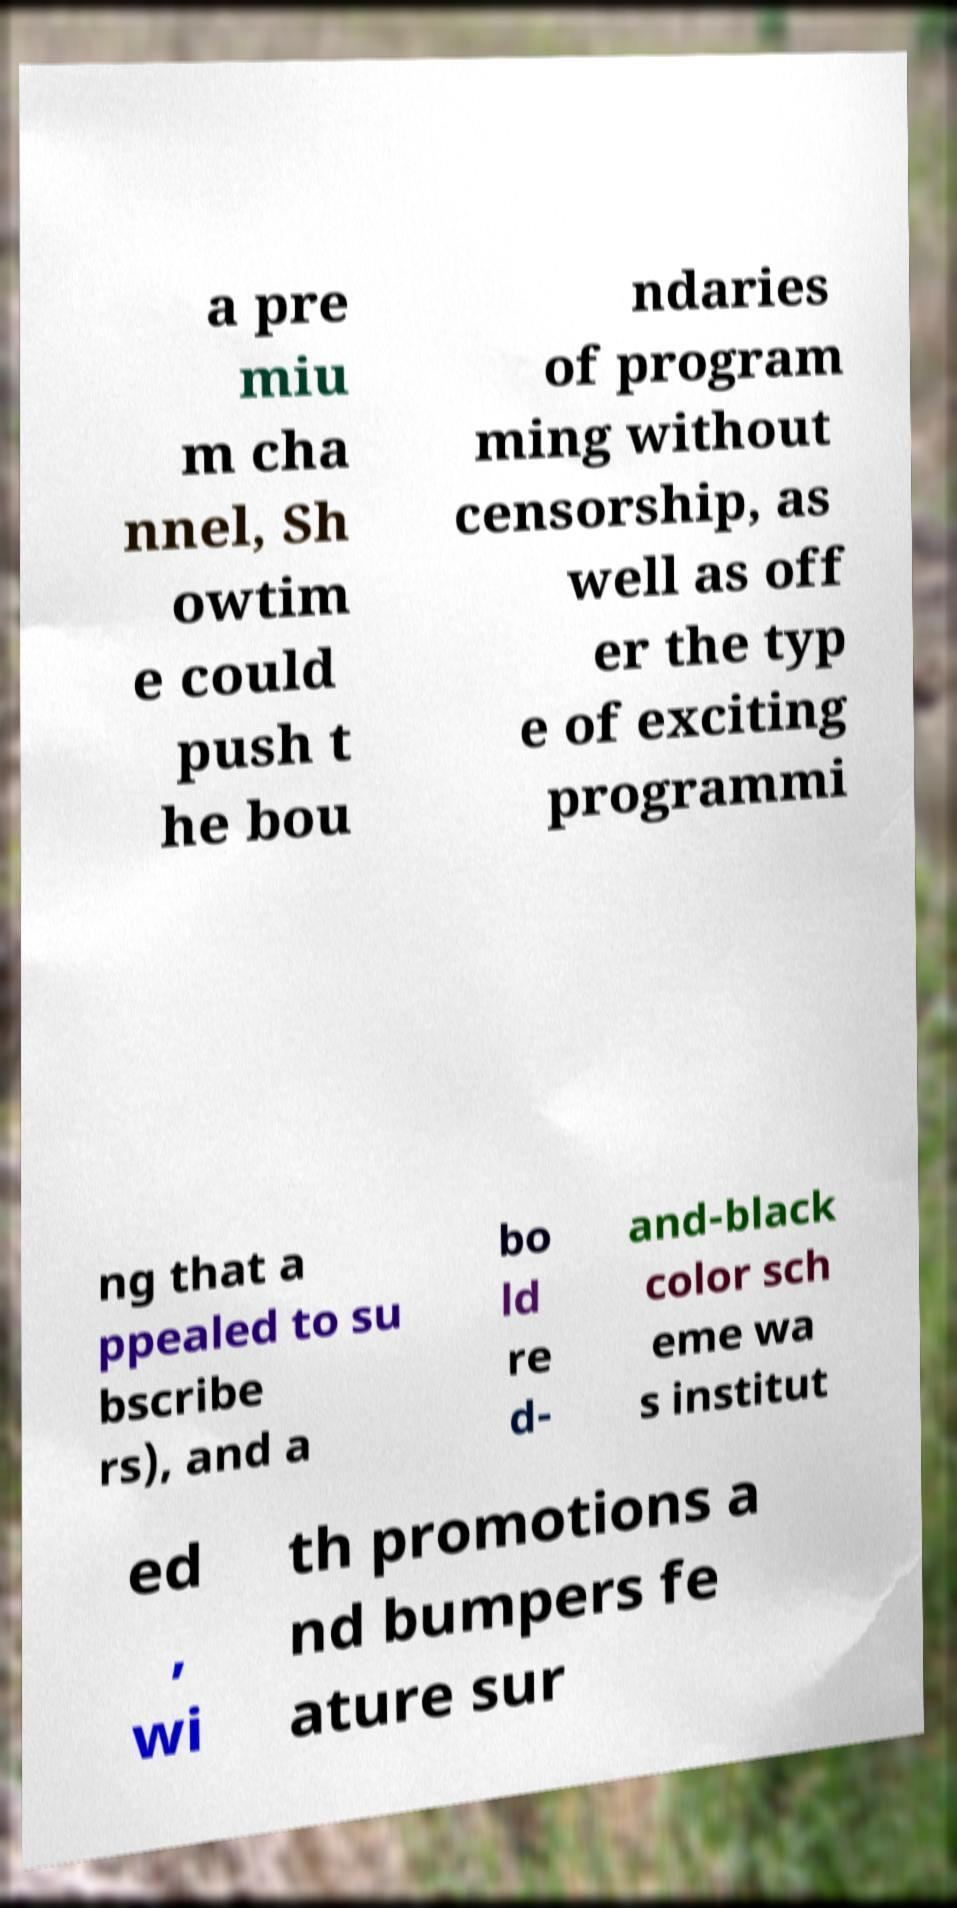Can you accurately transcribe the text from the provided image for me? a pre miu m cha nnel, Sh owtim e could push t he bou ndaries of program ming without censorship, as well as off er the typ e of exciting programmi ng that a ppealed to su bscribe rs), and a bo ld re d- and-black color sch eme wa s institut ed , wi th promotions a nd bumpers fe ature sur 